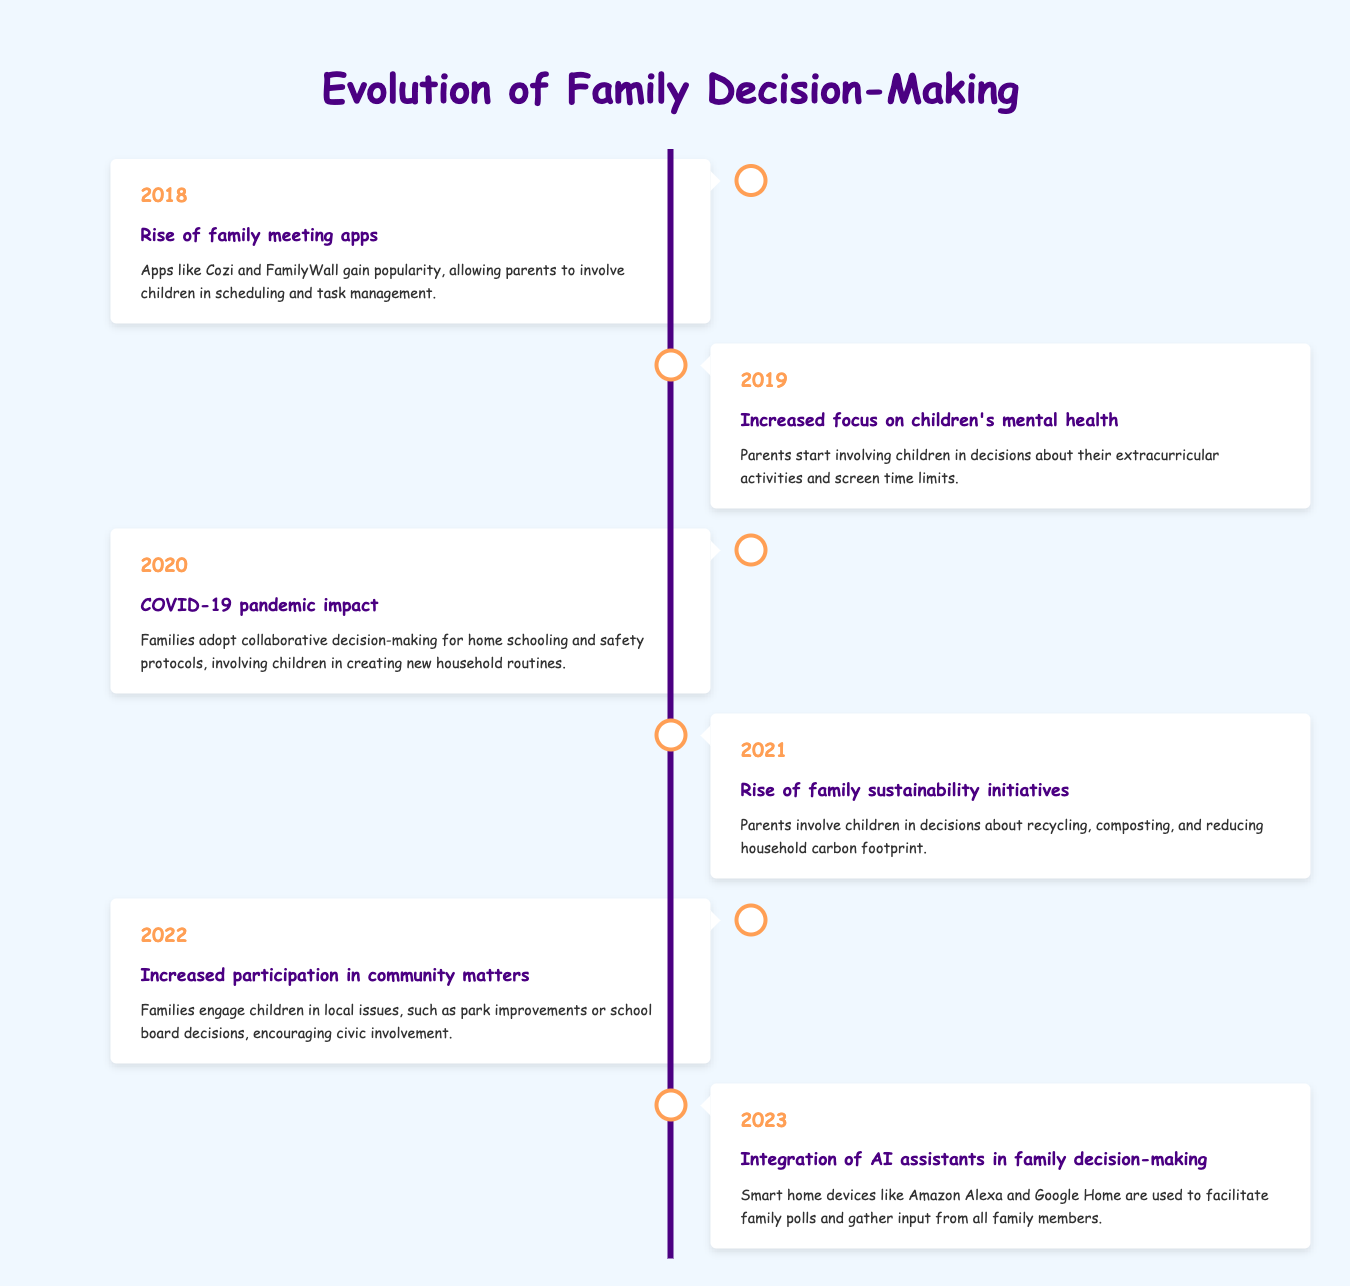What year did the COVID-19 pandemic impact family decision-making? According to the timeline, the event related to the COVID-19 pandemic is listed under the year 2020.
Answer: 2020 What specific decision-making trend in 2019 focused on children? The event in 2019 highlights an "Increased focus on children's mental health," indicating parents involving children in decisions about extracurricular activities and screen time.
Answer: Increased focus on children's mental health Did families start using technology to aid decision-making in 2018? Yes, the timeline specifies that in 2018, apps like Cozi and FamilyWall gained popularity, which allowed parents to involve children in scheduling and task management.
Answer: Yes How many years were there events related to sustainability initiatives? Reviewing the timeline, there is one event regarding sustainability initiatives in 2021. Therefore, there was 1 year dedicated to this theme.
Answer: 1 year In which year did families start integrating AI assistants for decision-making? The timeline indicates that the integration of AI assistants into family decision-making occurred in 2023.
Answer: 2023 What is the trend of children being involved in community matters, and when did it start? The timeline shows that in 2022, there was an increased participation in community matters, indicating that families started engaging children in local issues like park improvements and school board decisions.
Answer: 2022 Which event involved children creating new routines at home? The event related to children creating new household routines is from the year 2020, which discusses the impact of the COVID-19 pandemic on family decision-making.
Answer: 2020 What years involved families engaging children in both home-related and community-related decisions? From the timeline, 2020 involved home-related decisions during the pandemic, and 2022 involved community issues. Therefore, the years 2020 and 2022 both fit this criterion.
Answer: 2020 and 2022 Was there a significant event in 2021 regarding household decisions? Yes, in 2021, there was a "Rise of family sustainability initiatives" where parents involved children in decisions about recycling and reducing carbon footprint.
Answer: Yes 